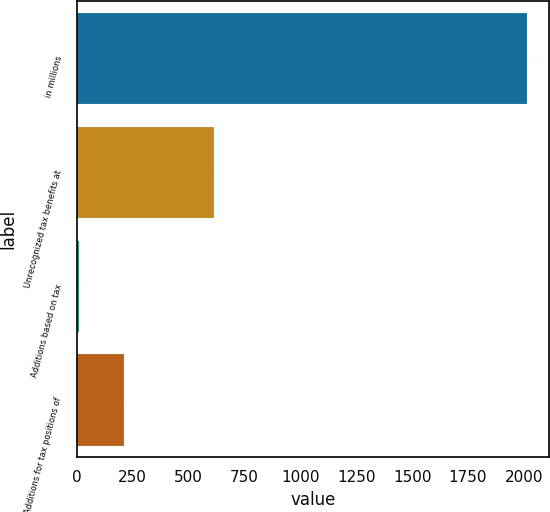<chart> <loc_0><loc_0><loc_500><loc_500><bar_chart><fcel>in millions<fcel>Unrecognized tax benefits at<fcel>Additions based on tax<fcel>Additions for tax positions of<nl><fcel>2012<fcel>612<fcel>12<fcel>212<nl></chart> 